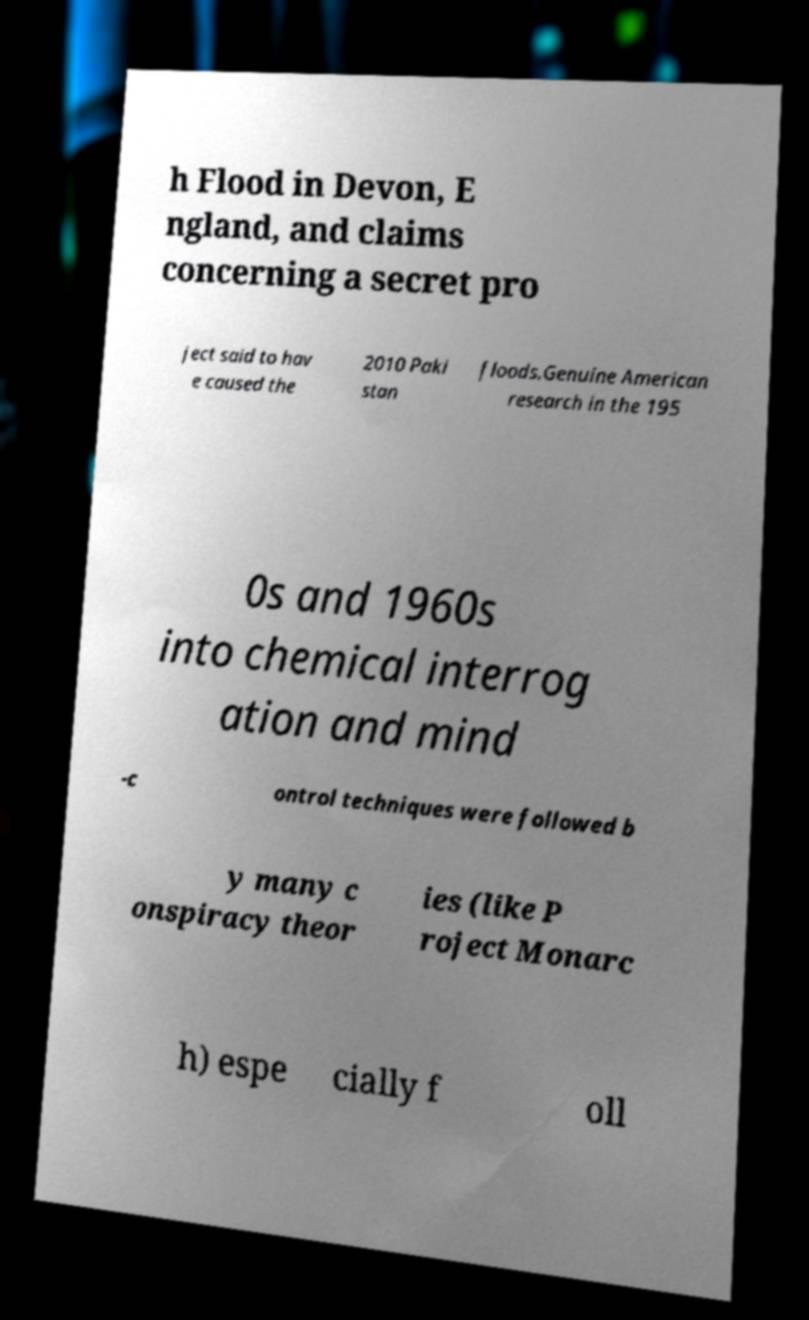Please read and relay the text visible in this image. What does it say? h Flood in Devon, E ngland, and claims concerning a secret pro ject said to hav e caused the 2010 Paki stan floods.Genuine American research in the 195 0s and 1960s into chemical interrog ation and mind -c ontrol techniques were followed b y many c onspiracy theor ies (like P roject Monarc h) espe cially f oll 